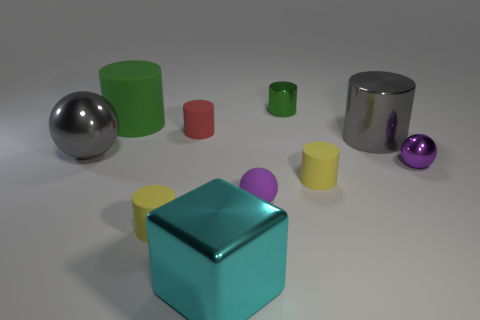There is a small purple shiny thing that is to the right of the tiny red object; what is its shape?
Provide a succinct answer. Sphere. Is the number of yellow cylinders that are in front of the tiny purple rubber object less than the number of red objects in front of the red cylinder?
Give a very brief answer. No. Is the material of the big gray thing on the right side of the large cyan metal cube the same as the big gray object that is on the left side of the cyan metal thing?
Give a very brief answer. Yes. The green metallic thing has what shape?
Make the answer very short. Cylinder. Is the number of purple balls to the right of the small purple matte sphere greater than the number of small yellow cylinders that are on the left side of the small green cylinder?
Make the answer very short. No. There is a gray object behind the big gray ball; is it the same shape as the gray thing on the left side of the large gray cylinder?
Provide a short and direct response. No. How many other objects are the same size as the purple metallic ball?
Your answer should be very brief. 5. What is the size of the gray cylinder?
Give a very brief answer. Large. Is the small green thing that is behind the large cyan shiny thing made of the same material as the red object?
Offer a very short reply. No. What is the color of the tiny shiny object that is the same shape as the green rubber thing?
Keep it short and to the point. Green. 